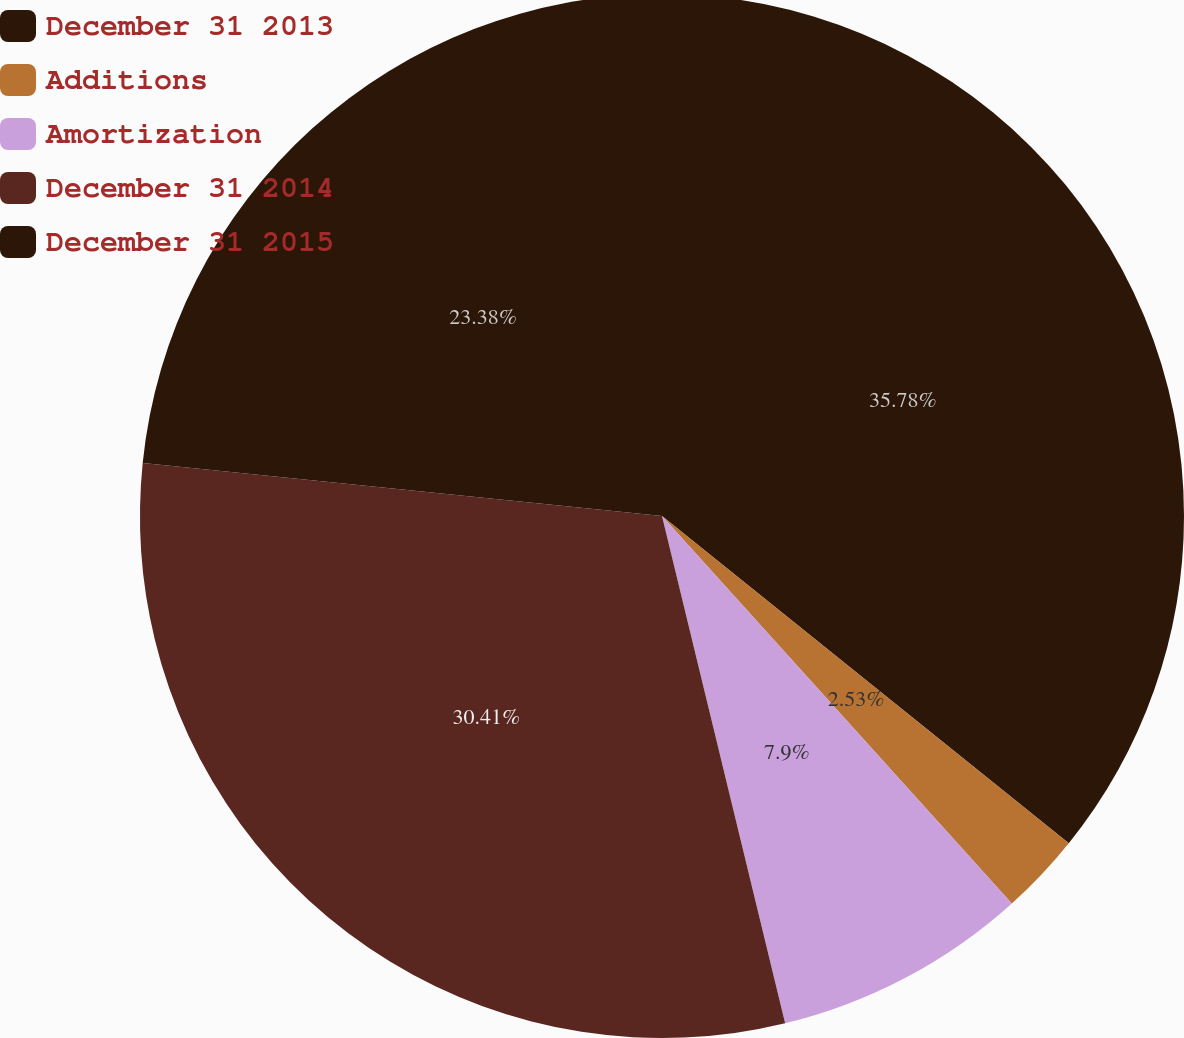Convert chart. <chart><loc_0><loc_0><loc_500><loc_500><pie_chart><fcel>December 31 2013<fcel>Additions<fcel>Amortization<fcel>December 31 2014<fcel>December 31 2015<nl><fcel>35.78%<fcel>2.53%<fcel>7.9%<fcel>30.41%<fcel>23.38%<nl></chart> 